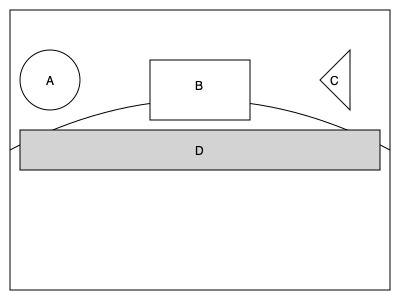In this cross-sectional diagram of a car, which labeled safety feature is specifically designed to absorb energy during a frontal collision and protect the passenger compartment? To answer this question, let's analyze each labeled component in the diagram:

1. Component A: This circular structure represents the steering wheel airbag. While it's an important safety feature, it's not primarily designed to absorb energy during a collision.

2. Component B: This rectangular structure in the middle of the car likely represents the passenger cabin. It's protected by other safety features but doesn't absorb energy itself.

3. Component C: This triangular structure at the front of the car represents the crumple zone. Crumple zones are specifically engineered to deform and absorb energy during a frontal collision, protecting the passenger compartment.

4. Component D: This horizontal structure along the bottom of the car represents the frame or chassis. While it contributes to overall structural integrity, it's not the primary energy-absorbing component in a frontal collision.

Among these components, the crumple zone (C) is specifically designed to absorb energy during a frontal collision. It does this by deforming in a controlled manner, dissipating the kinetic energy of the impact and reducing the force transmitted to the passenger compartment. This helps protect the occupants by slowing down the deceleration of the passenger cabin during a crash.

As a photojournalist specializing in crash tests, you would often capture images of how these crumple zones deform during collisions, demonstrating their crucial role in vehicle safety.
Answer: Crumple zone (C) 